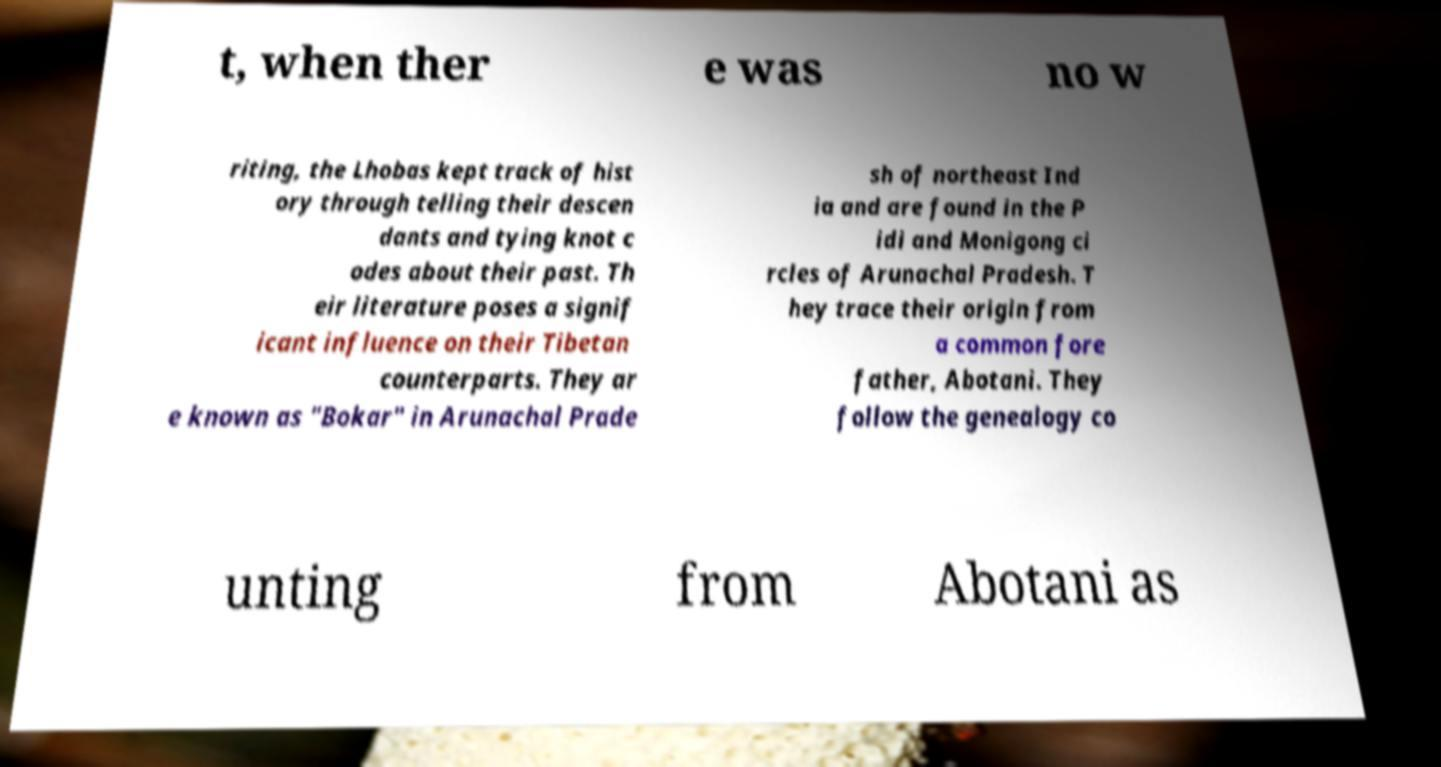I need the written content from this picture converted into text. Can you do that? t, when ther e was no w riting, the Lhobas kept track of hist ory through telling their descen dants and tying knot c odes about their past. Th eir literature poses a signif icant influence on their Tibetan counterparts. They ar e known as "Bokar" in Arunachal Prade sh of northeast Ind ia and are found in the P idi and Monigong ci rcles of Arunachal Pradesh. T hey trace their origin from a common fore father, Abotani. They follow the genealogy co unting from Abotani as 